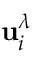Convert formula to latex. <formula><loc_0><loc_0><loc_500><loc_500>u _ { i } ^ { \lambda }</formula> 